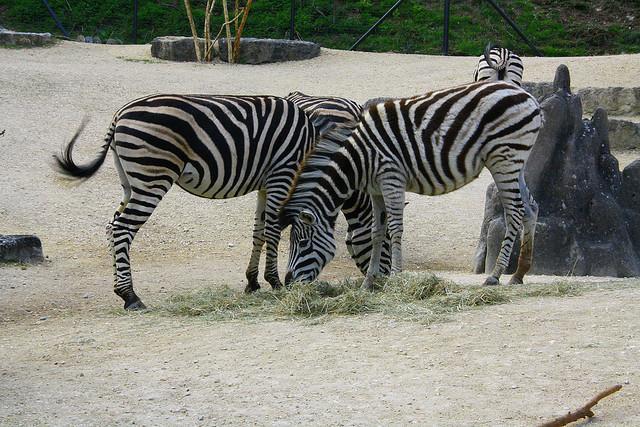How many zebras are at the zoo?
Give a very brief answer. 3. How many zebras are shown?
Give a very brief answer. 3. How many zebras are there?
Give a very brief answer. 2. How many men are standing on this boat?
Give a very brief answer. 0. 